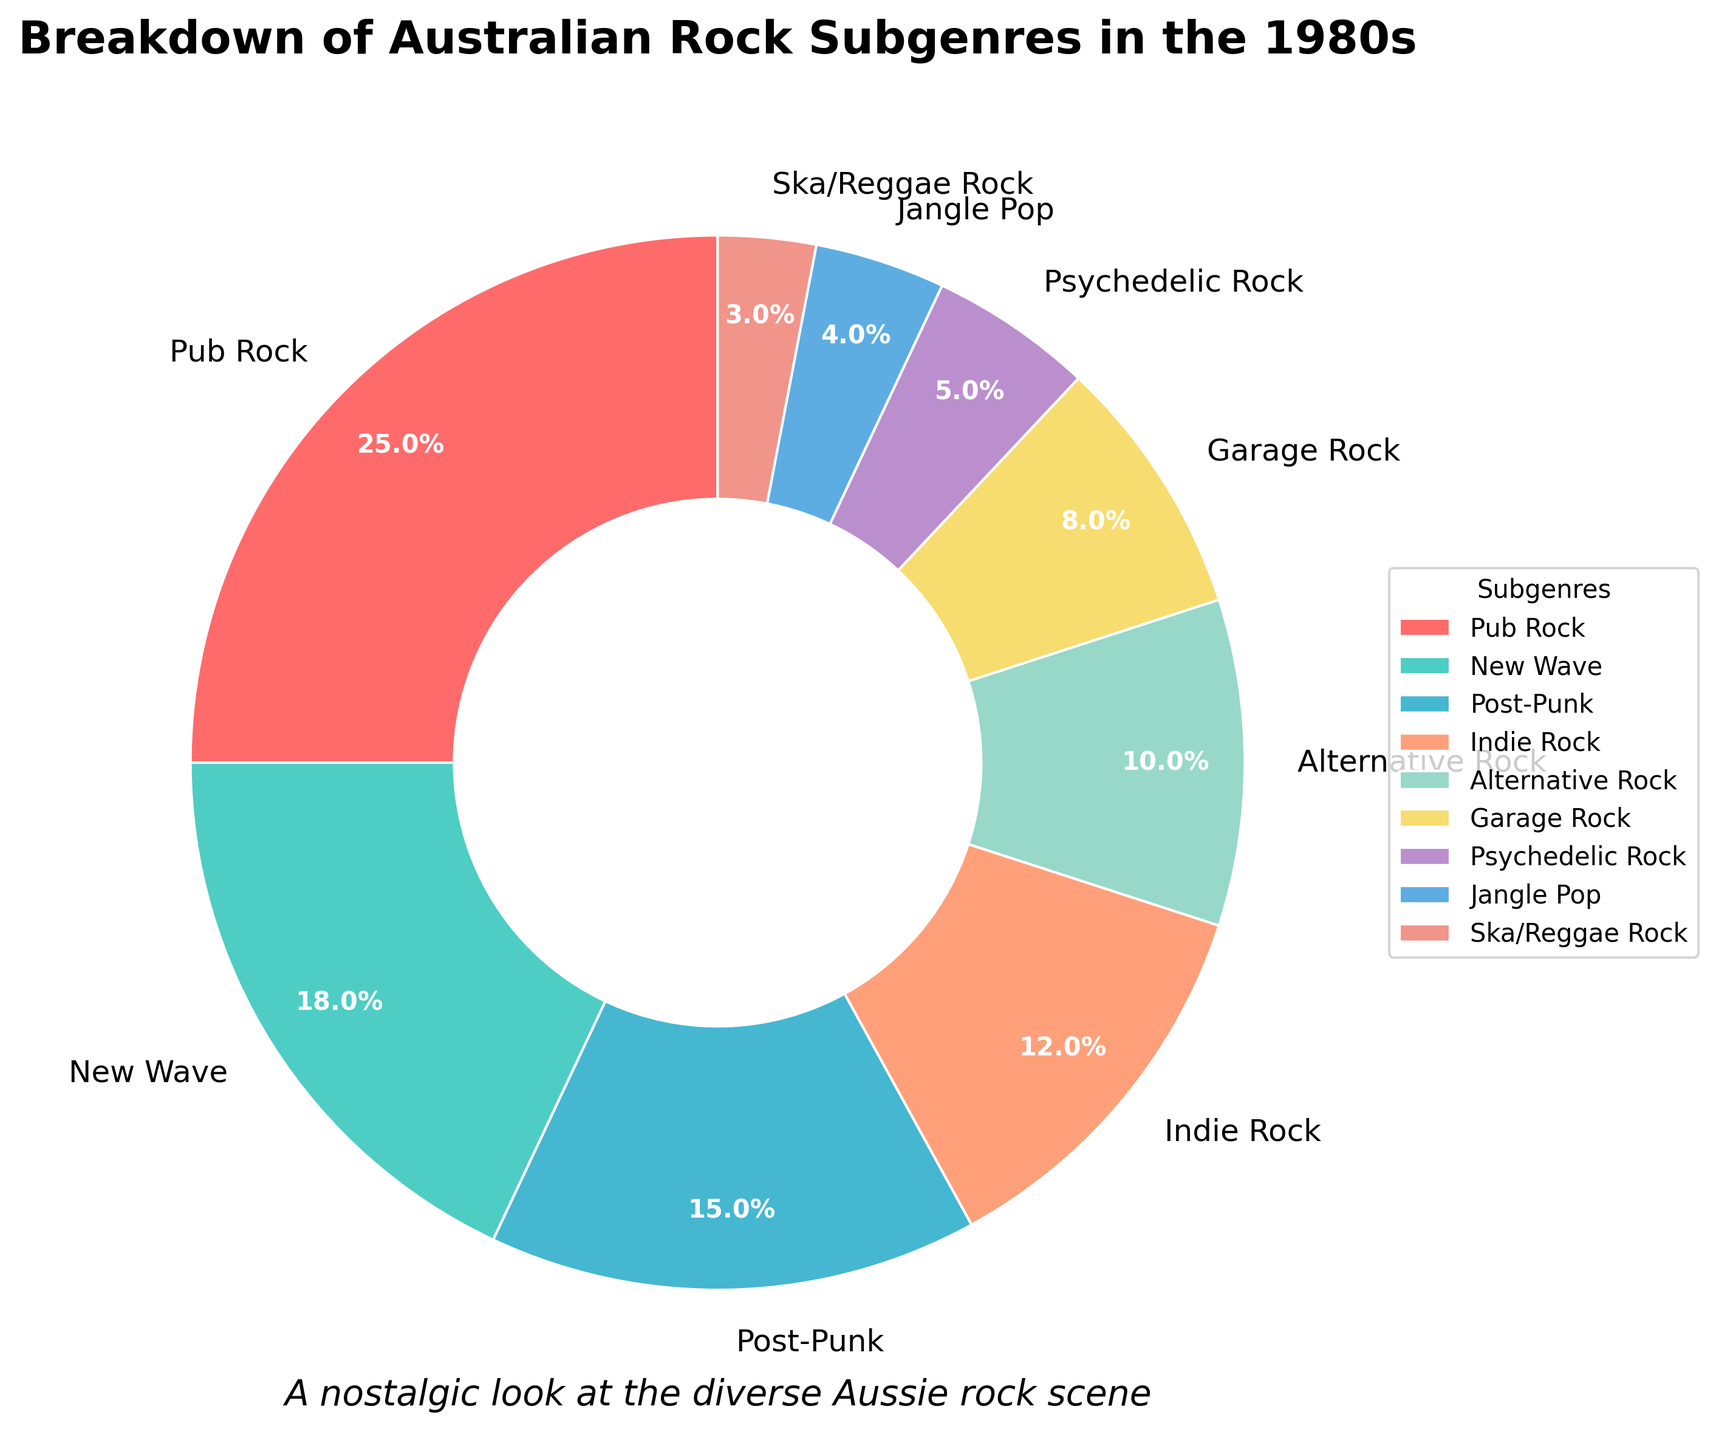What's the most popular Australian rock subgenre popularized in the 1980s? The pie chart shows that Pub Rock has the largest portion of the pie, making it the most popular subgenre.
Answer: Pub Rock Which subgenre has the second highest percentage of popularity? From the pie chart, the New Wave section is the next largest after Pub Rock.
Answer: New Wave What's the combined percentage of Garage Rock and Psychedelic Rock? Garage Rock is 8% and Psychedelic Rock is 5%. Adding these together, 8 + 5 = 13%.
Answer: 13% Does Indie Rock or Post-Punk have a larger share of the Australian rock scene in the 1980s? Indie Rock is shown to have 12%, whereas Post-Punk has 15%, indicating that Post-Punk has a larger share.
Answer: Post-Punk What's the total percentage of the lesser-represented subgenres (i.e., those with less than 10%)? Subgenres with less than 10%: Garage Rock (8%), Psychedelic Rock (5%), Jangle Pop (4%), Ska/Reggae Rock (3%). Adding these together, 8 + 5 + 4 + 3 = 20%.
Answer: 20% Which subgenre has a percentage closest to 10%? The pie chart indicates that Alternative Rock has a segment representing exactly 10%.
Answer: Alternative Rock Among the subgenres, which occupies a larger percentage, Indie Rock or Psychedelic Rock? Comparing the percentages, Indie Rock has 12% while Psychedelic Rock has 5%. Indie Rock is larger.
Answer: Indie Rock Calculate the difference in popularity between the most and least popular subgenres. The most popular is Pub Rock at 25%, and the least popular is Ska/Reggae Rock at 3%. The difference is 25 - 3 = 22%.
Answer: 22% What color represents New Wave on the pie chart? The pie chart uses colors to distinguish each subgenre, and New Wave is represented by a shade of cyan/turquoise.
Answer: Cyan Is the combined percentage of Post-Punk and New Wave greater than the combined percentage of Indie Rock and Alternative Rock? Post-Punk (15%) + New Wave (18%) = 33%, and Indie Rock (12%) + Alternative Rock (10%) = 22%. Since 33% is greater than 22%, the combined percentage of Post-Punk and New Wave is higher.
Answer: Yes 